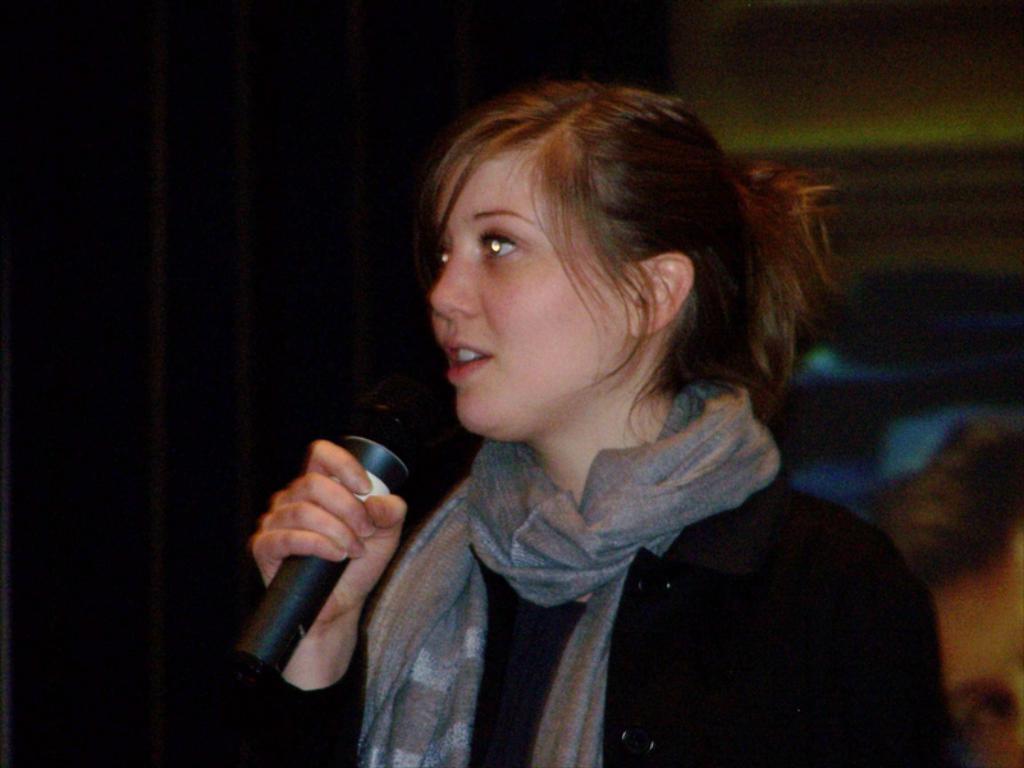Please provide a concise description of this image. In this picture we can see a woman holding a mike with her hand. And she is in black color dress. 